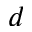Convert formula to latex. <formula><loc_0><loc_0><loc_500><loc_500>d</formula> 